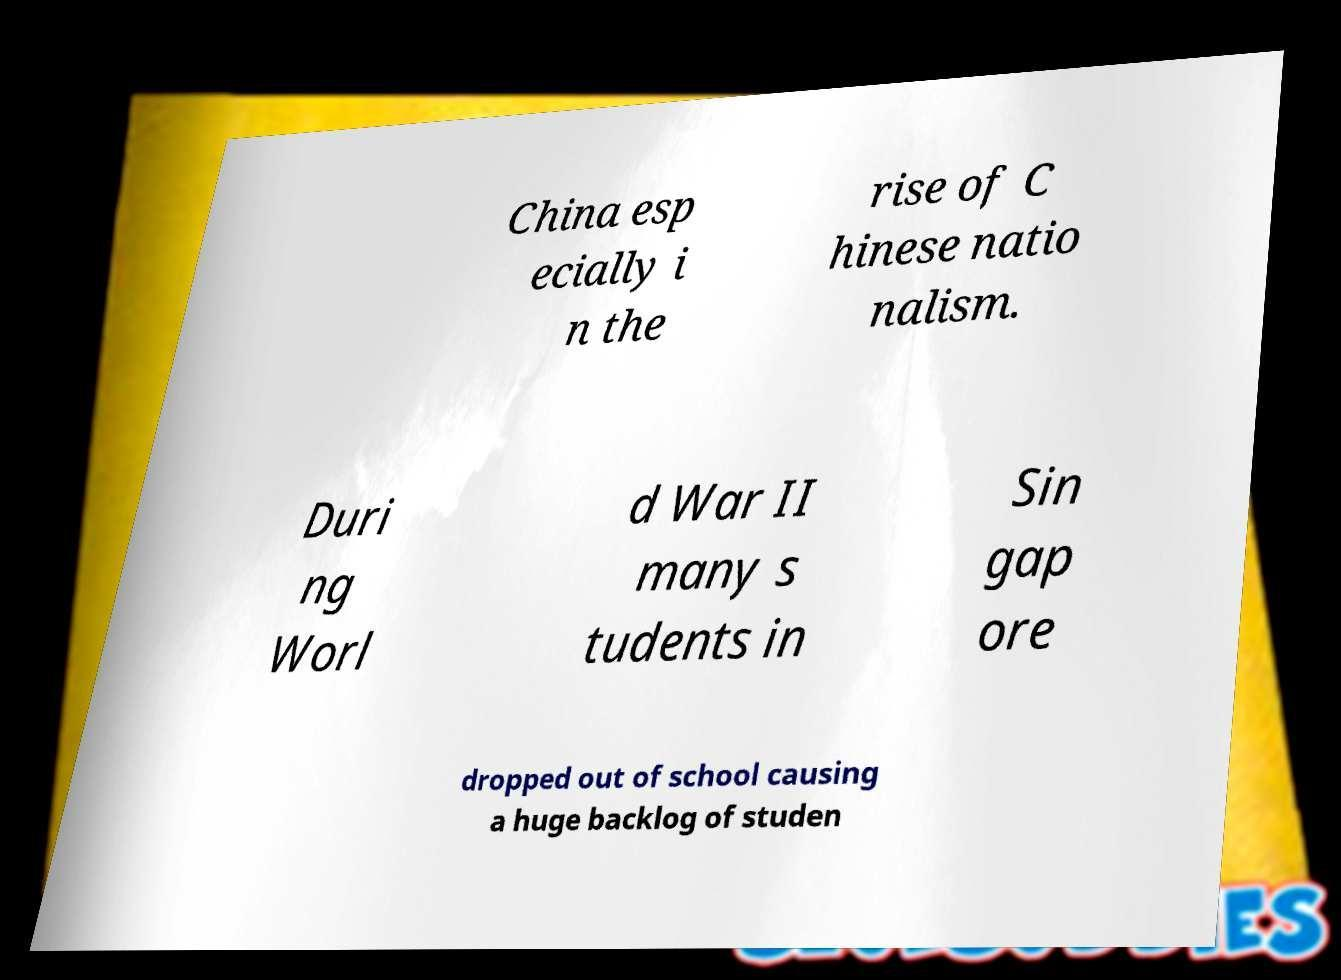Please identify and transcribe the text found in this image. China esp ecially i n the rise of C hinese natio nalism. Duri ng Worl d War II many s tudents in Sin gap ore dropped out of school causing a huge backlog of studen 